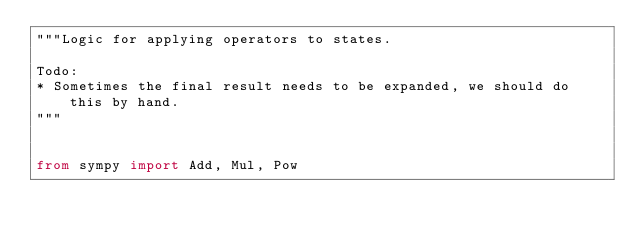<code> <loc_0><loc_0><loc_500><loc_500><_Python_>"""Logic for applying operators to states.

Todo:
* Sometimes the final result needs to be expanded, we should do this by hand.
"""


from sympy import Add, Mul, Pow
</code> 